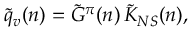<formula> <loc_0><loc_0><loc_500><loc_500>\tilde { q } _ { v } ( n ) = \tilde { G } ^ { \pi } ( n ) \, \tilde { K } _ { N S } ( n ) ,</formula> 